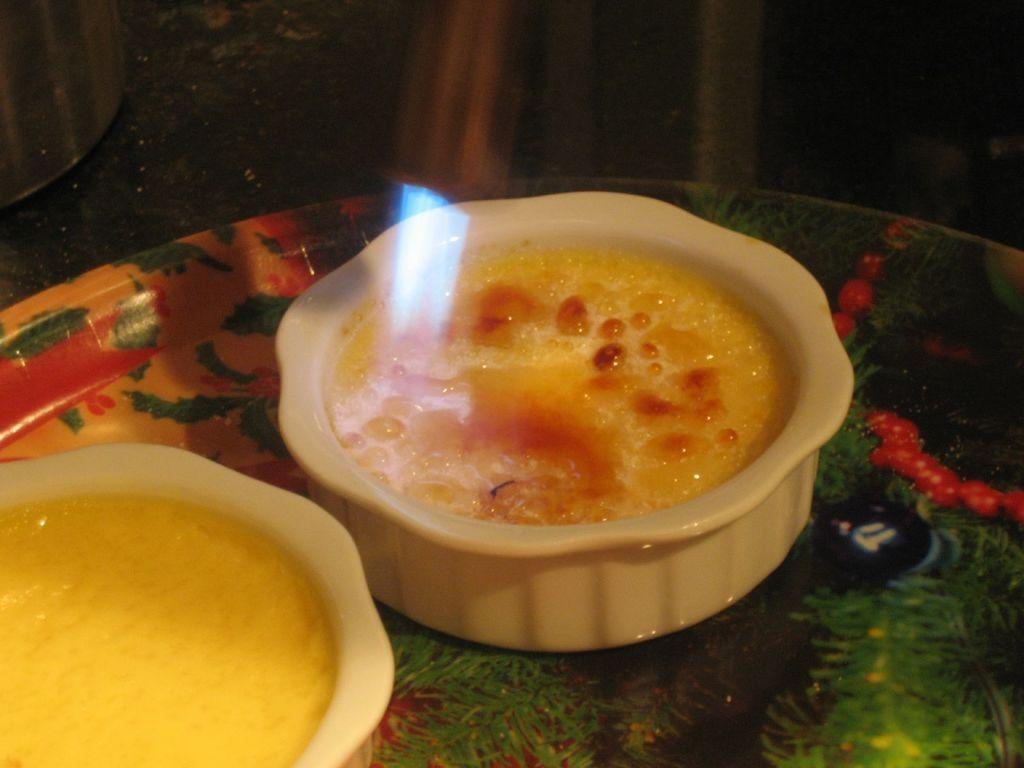What is in the bowl that is visible in the image? There are food items in a bowl in the image. How is the bowl positioned in the image? The bowl is on a plate in the image. Where is the bowl and plate located in the image? The bowl and plate are in the center of the image. How many trucks are visible in the image? There are no trucks present in the image. 